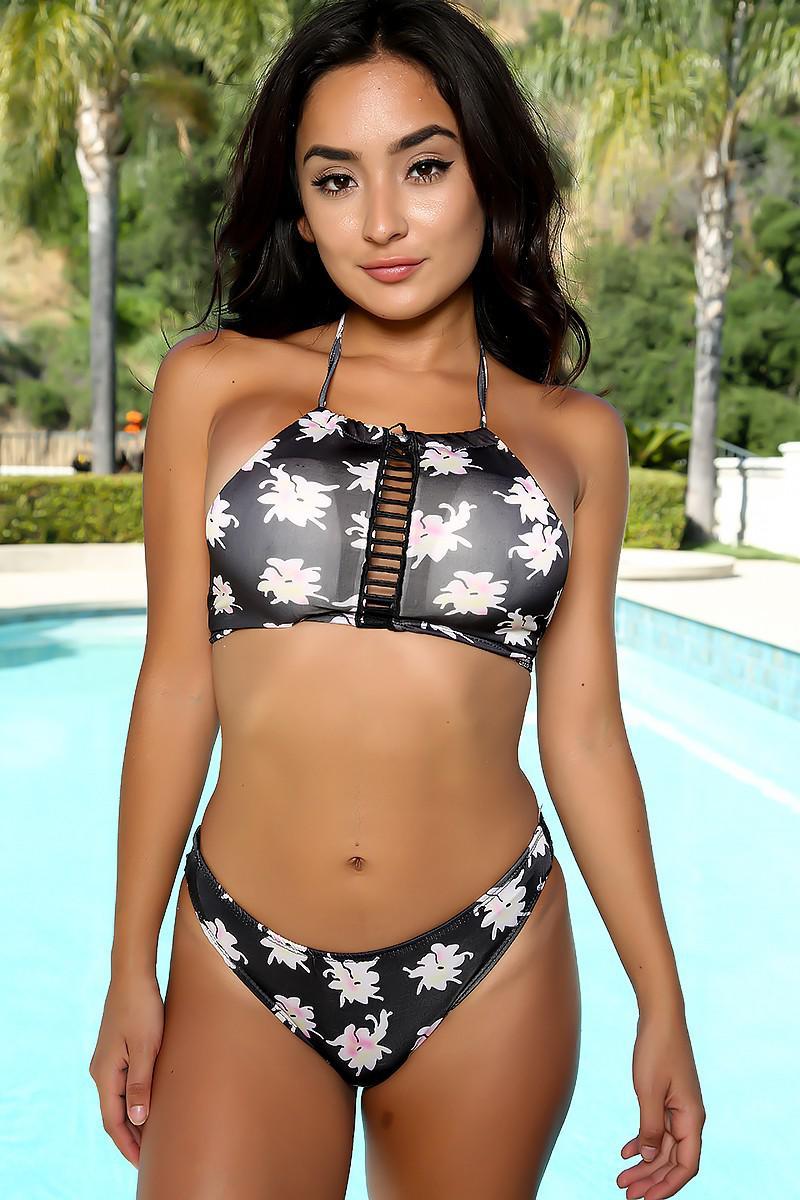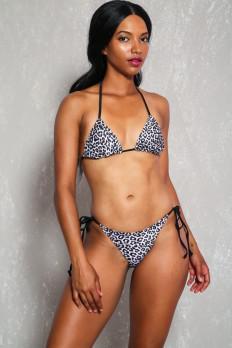The first image is the image on the left, the second image is the image on the right. For the images shown, is this caption "The swimsuit in the image on the left has a floral print." true? Answer yes or no. Yes. 